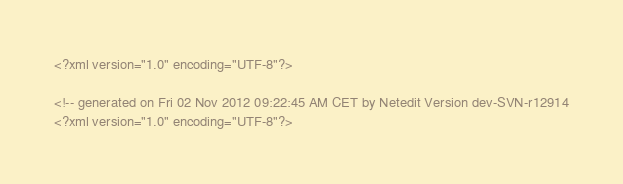<code> <loc_0><loc_0><loc_500><loc_500><_XML_><?xml version="1.0" encoding="UTF-8"?>

<!-- generated on Fri 02 Nov 2012 09:22:45 AM CET by Netedit Version dev-SVN-r12914
<?xml version="1.0" encoding="UTF-8"?>
</code> 